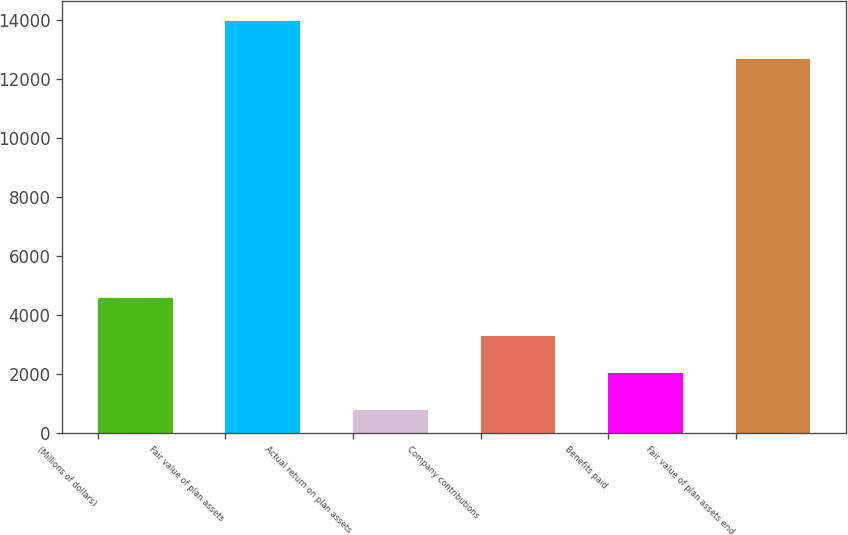<chart> <loc_0><loc_0><loc_500><loc_500><bar_chart><fcel>(Millions of dollars)<fcel>Fair value of plan assets<fcel>Actual return on plan assets<fcel>Company contributions<fcel>Benefits paid<fcel>Fair value of plan assets end<nl><fcel>4573.6<fcel>13960.2<fcel>784<fcel>3310.4<fcel>2047.2<fcel>12697<nl></chart> 